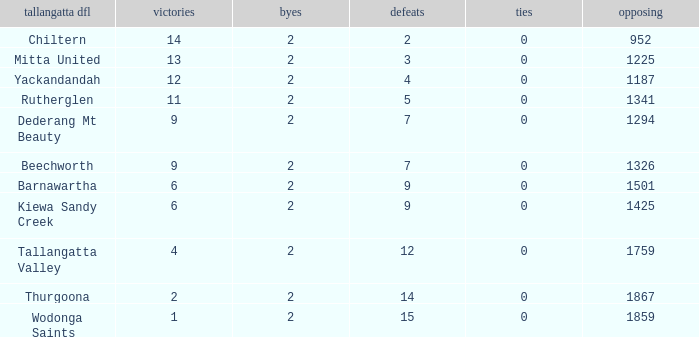What are the losses when there are 9 wins and more than 1326 against? None. Parse the full table. {'header': ['tallangatta dfl', 'victories', 'byes', 'defeats', 'ties', 'opposing'], 'rows': [['Chiltern', '14', '2', '2', '0', '952'], ['Mitta United', '13', '2', '3', '0', '1225'], ['Yackandandah', '12', '2', '4', '0', '1187'], ['Rutherglen', '11', '2', '5', '0', '1341'], ['Dederang Mt Beauty', '9', '2', '7', '0', '1294'], ['Beechworth', '9', '2', '7', '0', '1326'], ['Barnawartha', '6', '2', '9', '0', '1501'], ['Kiewa Sandy Creek', '6', '2', '9', '0', '1425'], ['Tallangatta Valley', '4', '2', '12', '0', '1759'], ['Thurgoona', '2', '2', '14', '0', '1867'], ['Wodonga Saints', '1', '2', '15', '0', '1859']]} 